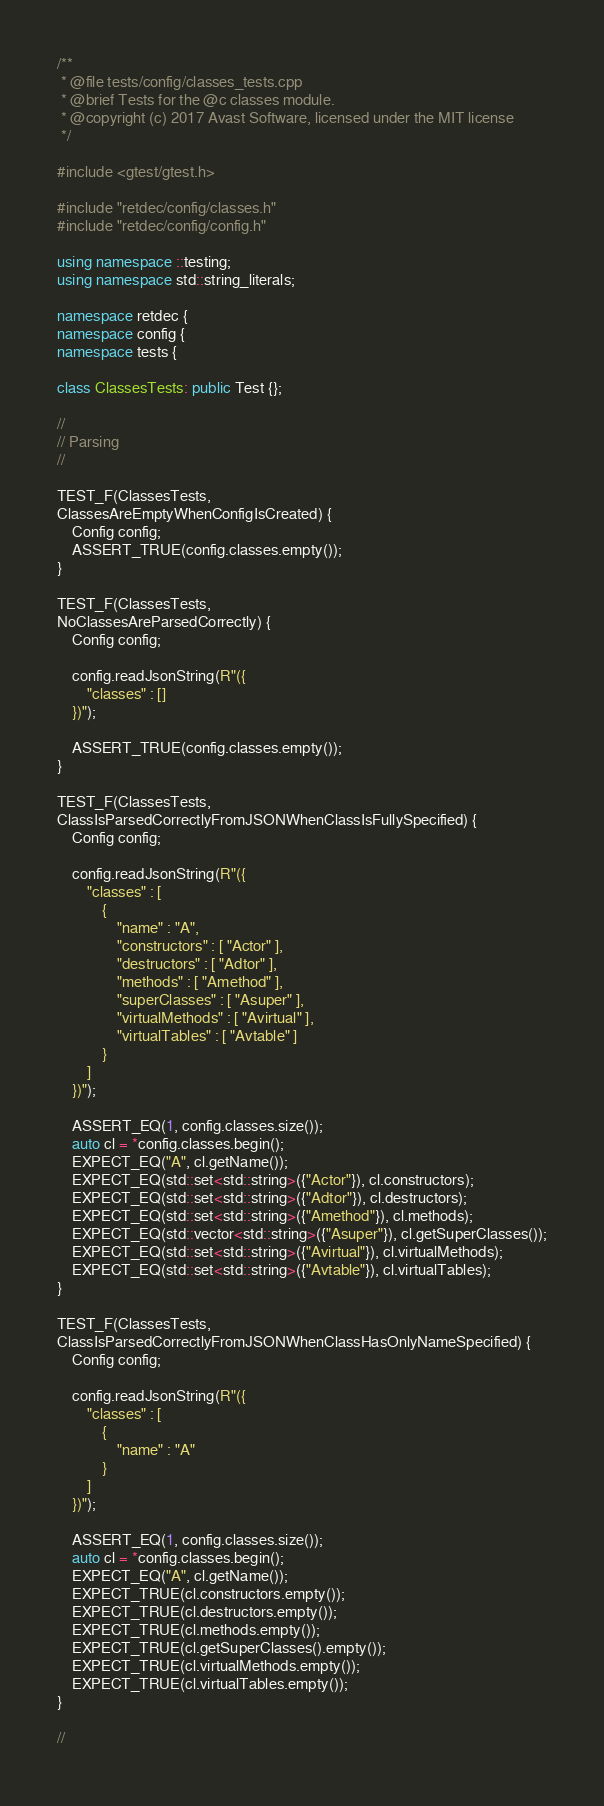Convert code to text. <code><loc_0><loc_0><loc_500><loc_500><_C++_>/**
 * @file tests/config/classes_tests.cpp
 * @brief Tests for the @c classes module.
 * @copyright (c) 2017 Avast Software, licensed under the MIT license
 */

#include <gtest/gtest.h>

#include "retdec/config/classes.h"
#include "retdec/config/config.h"

using namespace ::testing;
using namespace std::string_literals;

namespace retdec {
namespace config {
namespace tests {

class ClassesTests: public Test {};

//
// Parsing
//

TEST_F(ClassesTests,
ClassesAreEmptyWhenConfigIsCreated) {
	Config config;
	ASSERT_TRUE(config.classes.empty());
}

TEST_F(ClassesTests,
NoClassesAreParsedCorrectly) {
	Config config;

	config.readJsonString(R"({
		"classes" : []
	})");

	ASSERT_TRUE(config.classes.empty());
}

TEST_F(ClassesTests,
ClassIsParsedCorrectlyFromJSONWhenClassIsFullySpecified) {
	Config config;

	config.readJsonString(R"({
		"classes" : [
			{
				"name" : "A",
				"constructors" : [ "Actor" ],
				"destructors" : [ "Adtor" ],
				"methods" : [ "Amethod" ],
				"superClasses" : [ "Asuper" ],
				"virtualMethods" : [ "Avirtual" ],
				"virtualTables" : [ "Avtable" ]
			}
		]
	})");

	ASSERT_EQ(1, config.classes.size());
	auto cl = *config.classes.begin();
	EXPECT_EQ("A", cl.getName());
	EXPECT_EQ(std::set<std::string>({"Actor"}), cl.constructors);
	EXPECT_EQ(std::set<std::string>({"Adtor"}), cl.destructors);
	EXPECT_EQ(std::set<std::string>({"Amethod"}), cl.methods);
	EXPECT_EQ(std::vector<std::string>({"Asuper"}), cl.getSuperClasses());
	EXPECT_EQ(std::set<std::string>({"Avirtual"}), cl.virtualMethods);
	EXPECT_EQ(std::set<std::string>({"Avtable"}), cl.virtualTables);
}

TEST_F(ClassesTests,
ClassIsParsedCorrectlyFromJSONWhenClassHasOnlyNameSpecified) {
	Config config;

	config.readJsonString(R"({
		"classes" : [
			{
				"name" : "A"
			}
		]
	})");

	ASSERT_EQ(1, config.classes.size());
	auto cl = *config.classes.begin();
	EXPECT_EQ("A", cl.getName());
	EXPECT_TRUE(cl.constructors.empty());
	EXPECT_TRUE(cl.destructors.empty());
	EXPECT_TRUE(cl.methods.empty());
	EXPECT_TRUE(cl.getSuperClasses().empty());
	EXPECT_TRUE(cl.virtualMethods.empty());
	EXPECT_TRUE(cl.virtualTables.empty());
}

//</code> 